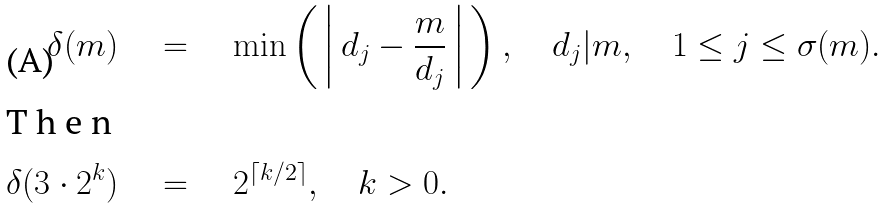<formula> <loc_0><loc_0><loc_500><loc_500>\delta ( m ) \quad & = \quad \min \left ( \, \left | \, d _ { j } - \frac { m } { d _ { j } } \, \right | \, \right ) , \quad d _ { j } | m , \quad 1 \leq j \leq \sigma ( m ) . \\ \intertext { T h e n } \delta ( 3 \cdot 2 ^ { k } ) \quad & = \quad 2 ^ { \lceil k / 2 \rceil } , \quad k > 0 .</formula> 